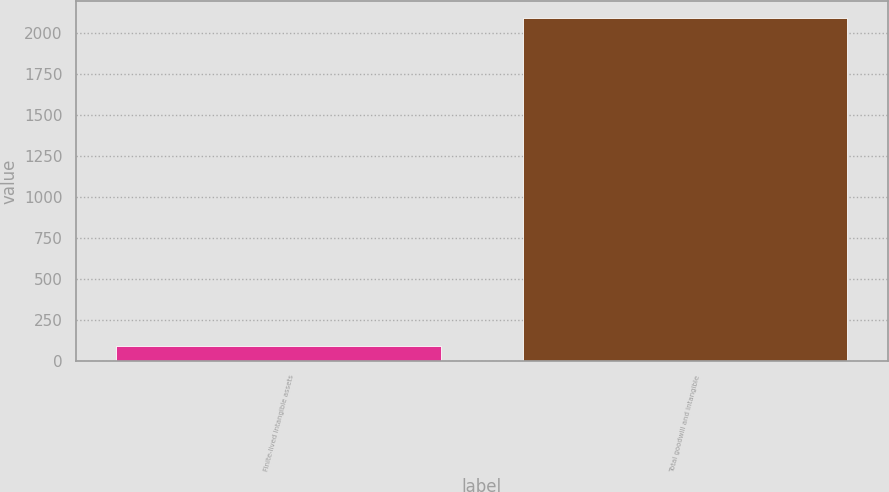<chart> <loc_0><loc_0><loc_500><loc_500><bar_chart><fcel>Finite-lived intangible assets<fcel>Total goodwill and intangible<nl><fcel>94.7<fcel>2087.7<nl></chart> 